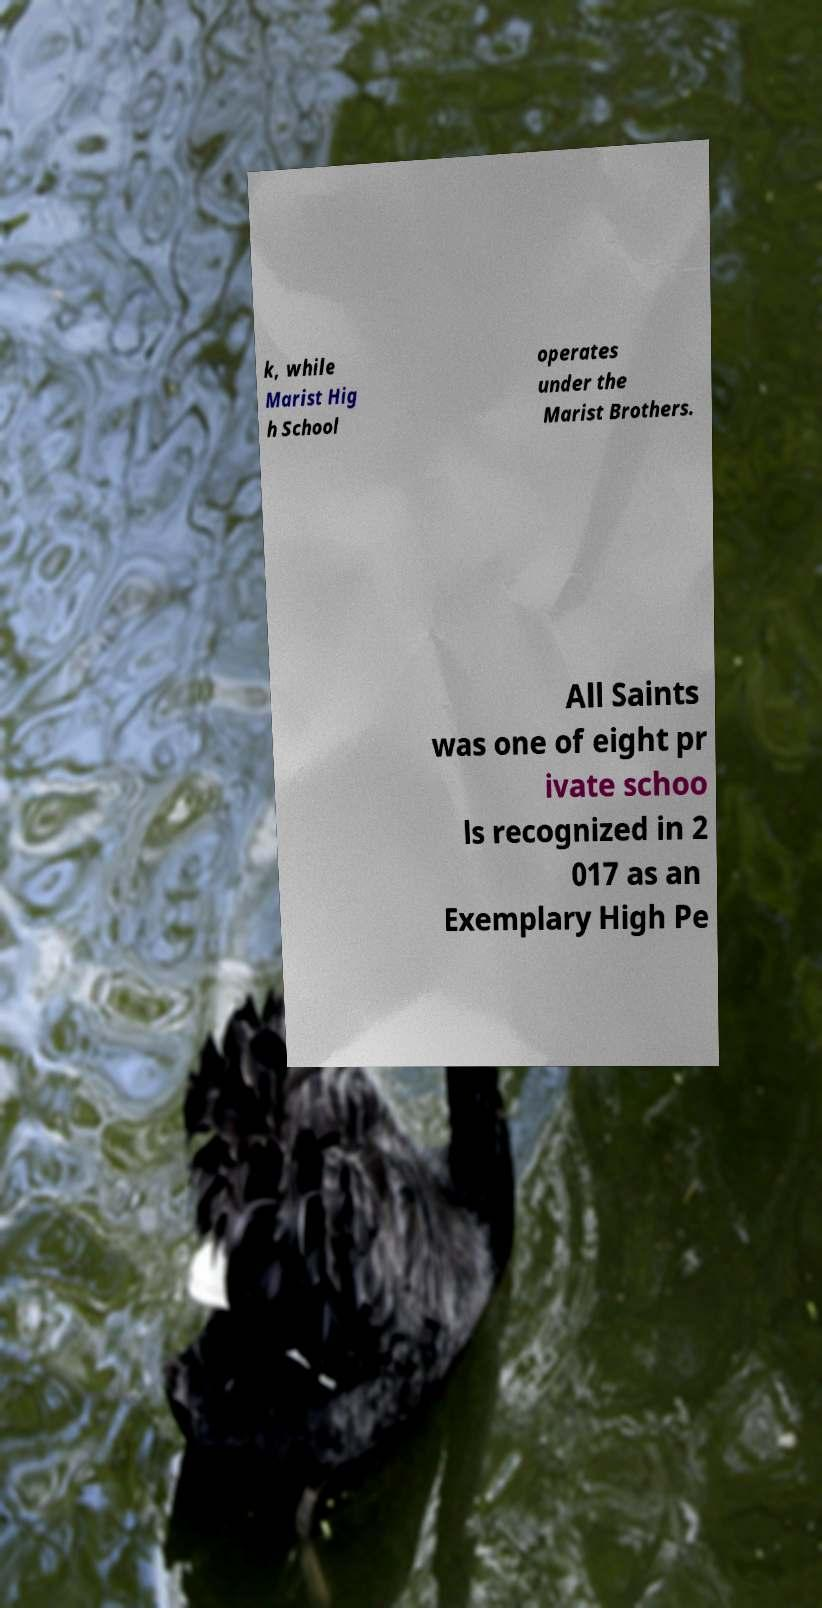Could you extract and type out the text from this image? k, while Marist Hig h School operates under the Marist Brothers. All Saints was one of eight pr ivate schoo ls recognized in 2 017 as an Exemplary High Pe 